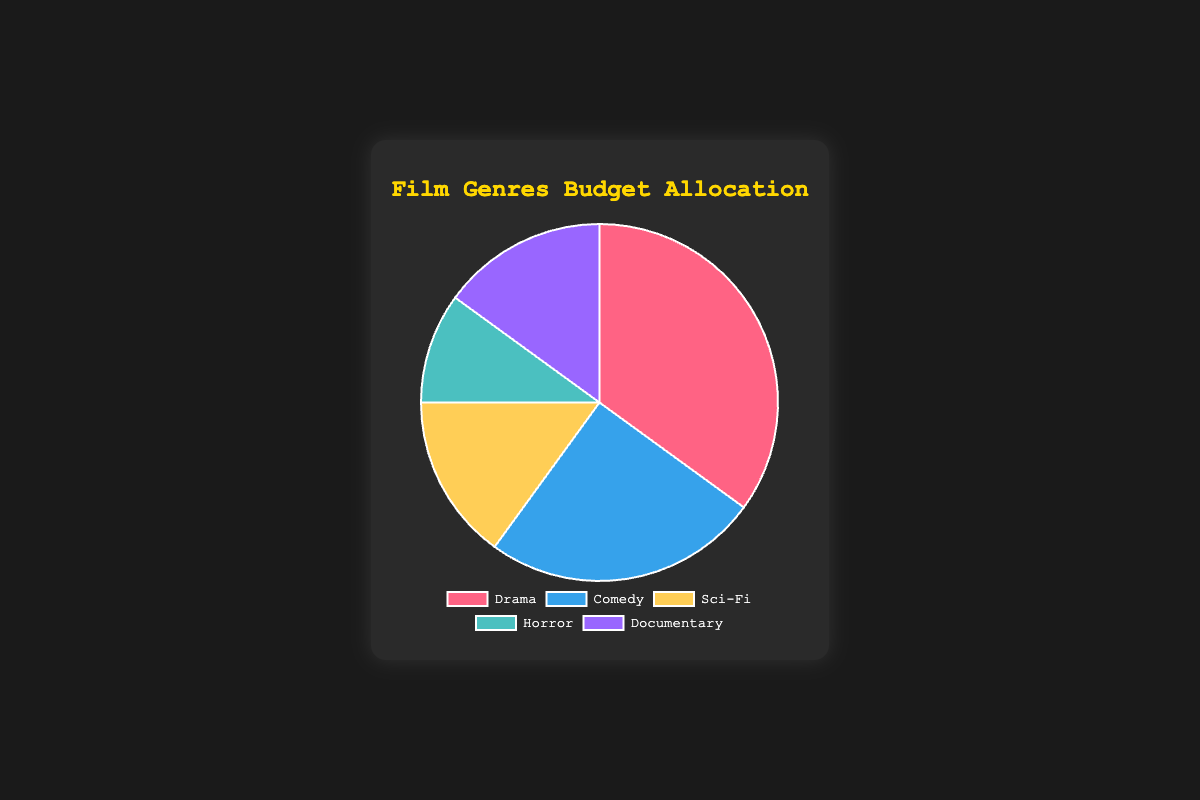Why is the Drama genre taking up the largest portion of the budget? The Drama genre has the highest budget allocation at 35%, indicating that it's a priority for preservation, likely due to its historical significance and popularity among classic films.
Answer: It has the highest budget allocation at 35% How does the budget allocation for Comedy compare to Sci-Fi? The budget allocation for Comedy is 25%, while Sci-Fi is 15%. Comedy has a greater allocation by 10 percentage points.
Answer: Comedy has 10% more allocation What percentage of the budget is allocated to Horror films? The pie chart shows that Horror films have a budget allocation of 10%.
Answer: 10% Which genres have the same budget allocation percentage? Both the Sci-Fi and Documentary genres have a budget allocation percentage of 15%.
Answer: Sci-Fi and Documentary What is the combined budget allocation percentage for Drama and Comedy? Drama has 35% and Comedy has 25%. Adding them together gives 35% + 25% = 60%.
Answer: 60% Which genre has the least budget allocated to it? The Horror genre has the smallest allocation with only 10%.
Answer: Horror How much more is allocated to Drama than Horror? Drama is allocated 35% and Horror 10%. The difference is 35% - 10% = 25%.
Answer: 25% What color represents the Documentary genre on the chart? The Documentary genre is represented by the color purple on the chart as per the last segment of the pie chart's color sequence.
Answer: Purple Is the total percentage of the budget for Sci-Fi and Documentary greater than Comedy? Both Sci-Fi and Documentary are 15% each, summing up to 30%. Comedy is allocated 25%. Since 30% is greater than 25%, the combined budget for Sci-Fi and Documentary is greater.
Answer: Yes What is the average budget allocation percentage for all the genres? Adding all the percentages together (35 + 25 + 15 + 10 + 15 = 100) and dividing by the number of genres (5) gives the average: 100 / 5 = 20%.
Answer: 20% 